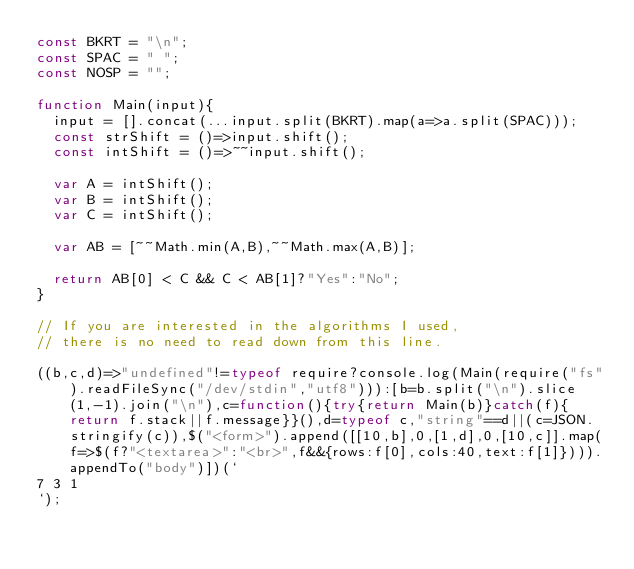Convert code to text. <code><loc_0><loc_0><loc_500><loc_500><_JavaScript_>const BKRT = "\n";
const SPAC = " ";
const NOSP = "";

function Main(input){
	input = [].concat(...input.split(BKRT).map(a=>a.split(SPAC)));
  const strShift = ()=>input.shift();
  const intShift = ()=>~~input.shift();
  
  var A = intShift();
  var B = intShift();
  var C = intShift();
  
  var AB = [~~Math.min(A,B),~~Math.max(A,B)];
  
  return AB[0] < C && C < AB[1]?"Yes":"No";
}

// If you are interested in the algorithms I used, 
// there is no need to read down from this line.

((b,c,d)=>"undefined"!=typeof require?console.log(Main(require("fs").readFileSync("/dev/stdin","utf8"))):[b=b.split("\n").slice(1,-1).join("\n"),c=function(){try{return Main(b)}catch(f){return f.stack||f.message}}(),d=typeof c,"string"==d||(c=JSON.stringify(c)),$("<form>").append([[10,b],0,[1,d],0,[10,c]].map(f=>$(f?"<textarea>":"<br>",f&&{rows:f[0],cols:40,text:f[1]}))).appendTo("body")])(`
7 3 1
`);</code> 